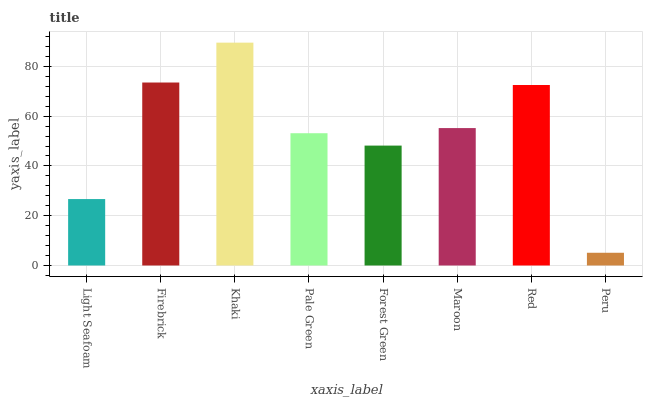Is Peru the minimum?
Answer yes or no. Yes. Is Khaki the maximum?
Answer yes or no. Yes. Is Firebrick the minimum?
Answer yes or no. No. Is Firebrick the maximum?
Answer yes or no. No. Is Firebrick greater than Light Seafoam?
Answer yes or no. Yes. Is Light Seafoam less than Firebrick?
Answer yes or no. Yes. Is Light Seafoam greater than Firebrick?
Answer yes or no. No. Is Firebrick less than Light Seafoam?
Answer yes or no. No. Is Maroon the high median?
Answer yes or no. Yes. Is Pale Green the low median?
Answer yes or no. Yes. Is Red the high median?
Answer yes or no. No. Is Maroon the low median?
Answer yes or no. No. 